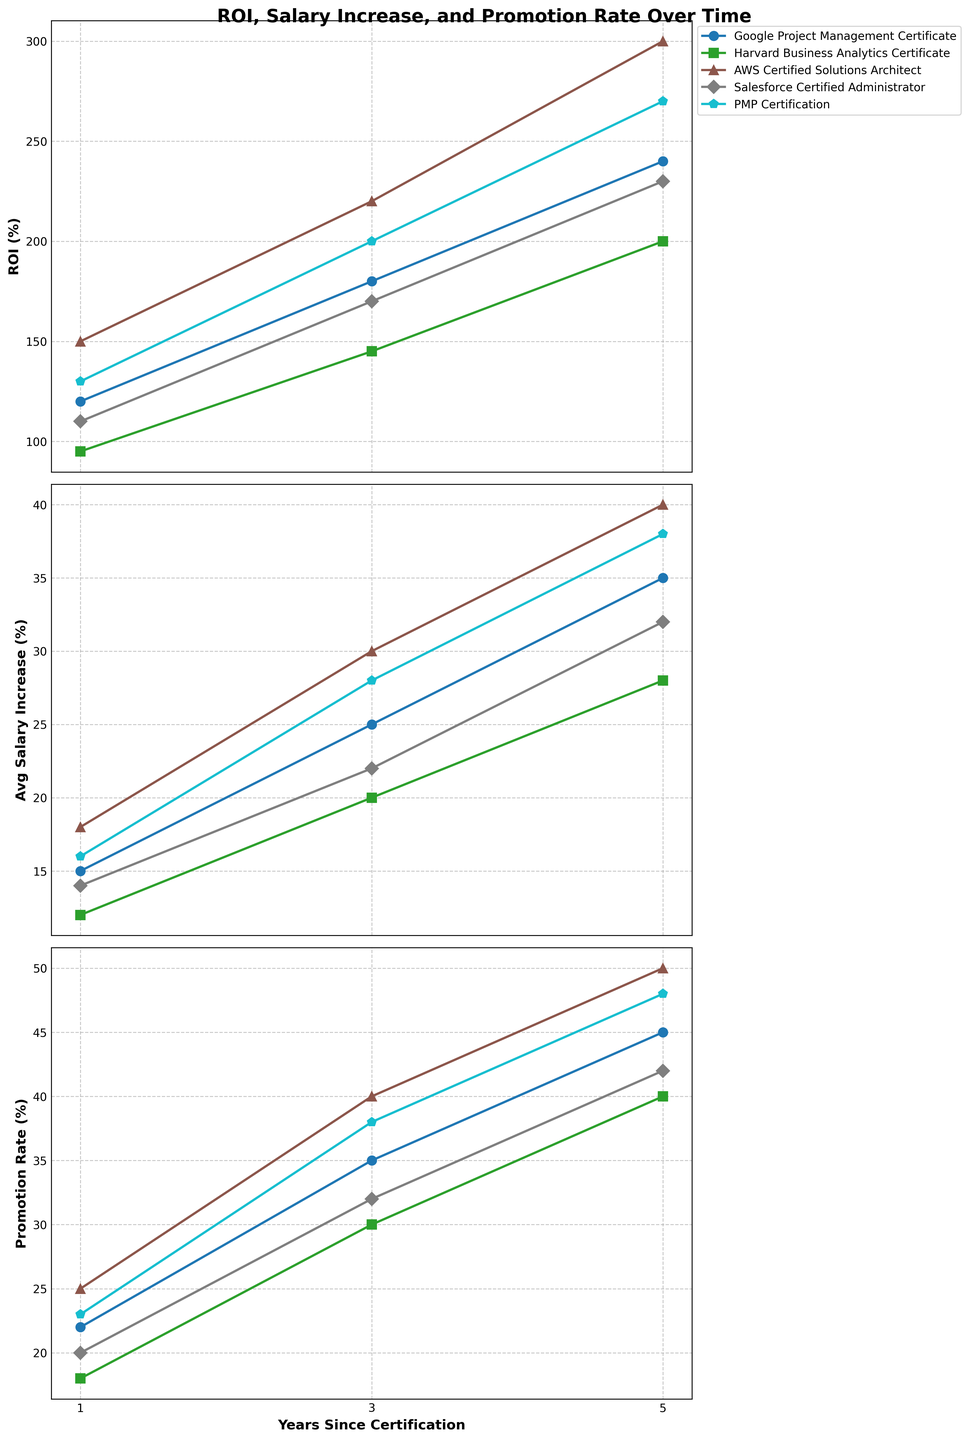How does the ROI for AWS Certified Solutions Architect change over the years? The ROI for AWS Certified Solutions Architect increases from 150% in year 1 to 220% in year 3 and to 300% in year 5. There is a consistent increase over the years.
Answer: Consistent increase from 150% to 300% Which program shows the highest average salary increase in year 3? By inspecting the average salary increase lines in year 3, AWS Certified Solutions Architect shows the highest average salary increase with 30%.
Answer: AWS Certified Solutions Architect Compare the ROI of Harvard Business Analytics Certificate and PMP Certification in year 5. Which one is higher and by how much? In year 5, PMP Certification has a ROI of 270%, while Harvard Business Analytics Certificate has a ROI of 200%. PMP Certification's ROI is higher by 70%.
Answer: PMP Certification by 70% What is the difference in the promotion rate between Salesforce Certified Administrator and Google Project Management Certificate in year 1? The promotion rate for Salesforce Certified Administrator is 20% and for Google Project Management Certificate is 22% in year 1. Therefore, the difference is 2%.
Answer: 2% Among the certifications listed, which one shows the highest promotion rate in year 5, and what is the value? AWS Certified Solutions Architect shows the highest promotion rate in year 5 with a value of 50%.
Answer: AWS Certified Solutions Architect, 50% How does the average salary increase for Google Project Management Certificate compare to Harvard Business Analytics Certificate in year 3? In year 3, the Google Project Management Certificate shows an average salary increase of 25%, whereas the Harvard Business Analytics Certificate shows a 20% increase. Google Project Management Certificate has a 5% higher salary increase.
Answer: Google Project Management Certificate by 5% What is the combined ROI for PMP Certification over all three years? The ROI for PMP Certification over the years is 130% in year 1, 200% in year 3, and 270% in year 5. The combined ROI is (130 + 200 + 270) = 600%.
Answer: 600% Between Google Project Management Certificate and Salesforce Certified Administrator, which program has the greater increase in ROI from year 3 to year 5? From year 3 to year 5, Google Project Management Certificate increases its ROI from 180% to 240%, an increase of 60%. Salesforce Certified Administrator increases its ROI from 170% to 230%, an increase of 60%. Both have an equal increase.
Answer: Both equal, 60% What is the average promotion rate over the three years for AWS Certified Solutions Architect? The promotion rates for AWS Certified Solutions Architect are 25% in year 1, 40% in year 3, and 50% in year 5. The average promotion rate is (25 + 40 + 50) / 3 = 38.33%.
Answer: 38.33% Looking at year 1, which program has the lowest average salary increase and what is the value? In year 1, Harvard Business Analytics Certificate has the lowest average salary increase with a value of 12%.
Answer: Harvard Business Analytics Certificate, 12% 